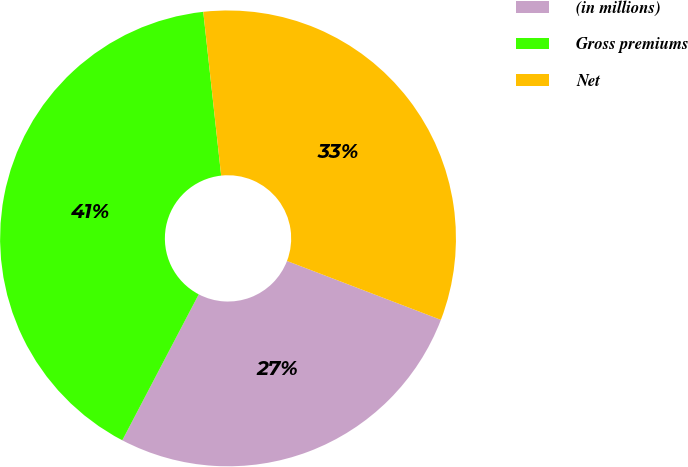<chart> <loc_0><loc_0><loc_500><loc_500><pie_chart><fcel>(in millions)<fcel>Gross premiums<fcel>Net<nl><fcel>26.86%<fcel>40.59%<fcel>32.55%<nl></chart> 